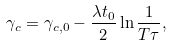Convert formula to latex. <formula><loc_0><loc_0><loc_500><loc_500>\gamma _ { c } = \gamma _ { c , 0 } - \frac { \lambda t _ { 0 } } { 2 } \ln \frac { 1 } { T \tau } ,</formula> 